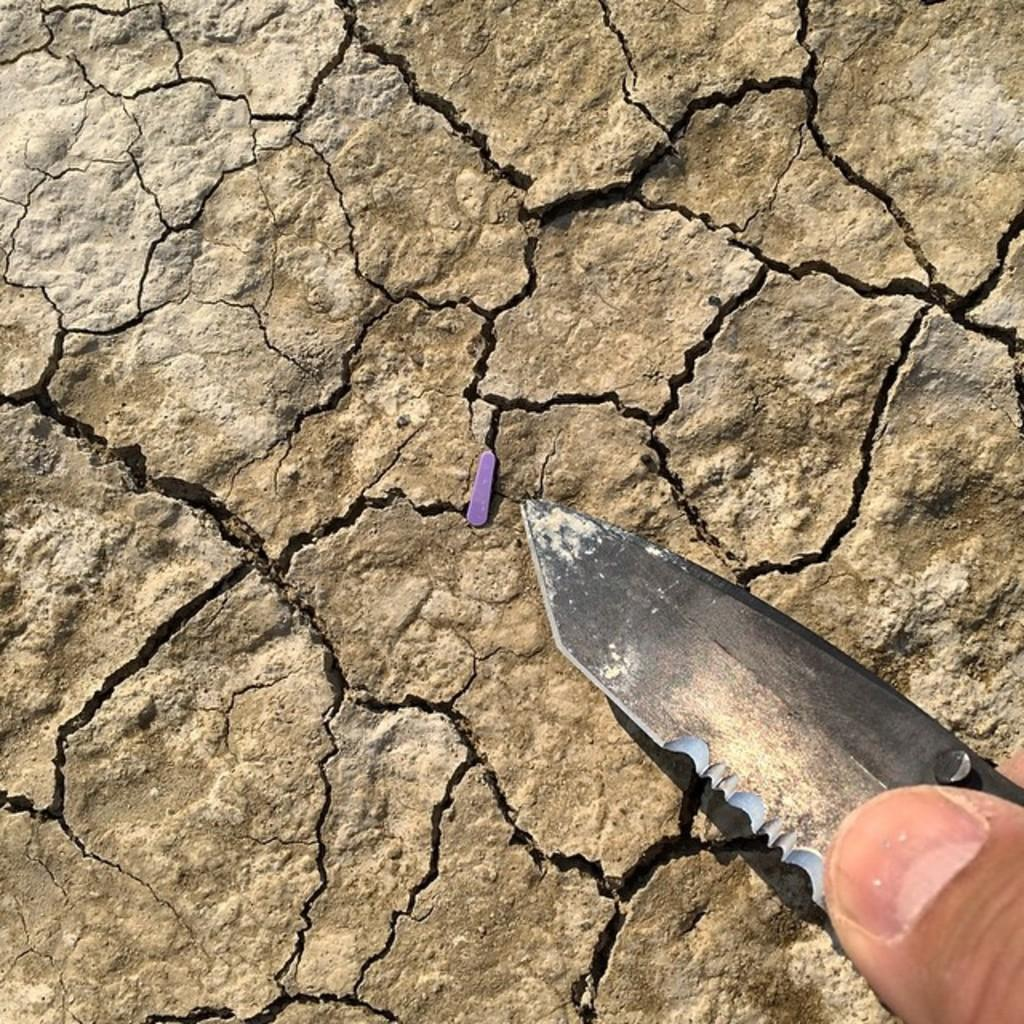What is the person in the image holding? The person is holding a knife in the image. Can you describe the object and the surface it is on? There is a purple object on a brown surface in the image. What type of street can be seen in the image? There is no street visible in the image. How much money is being exchanged in the image? There is no money present in the image. 